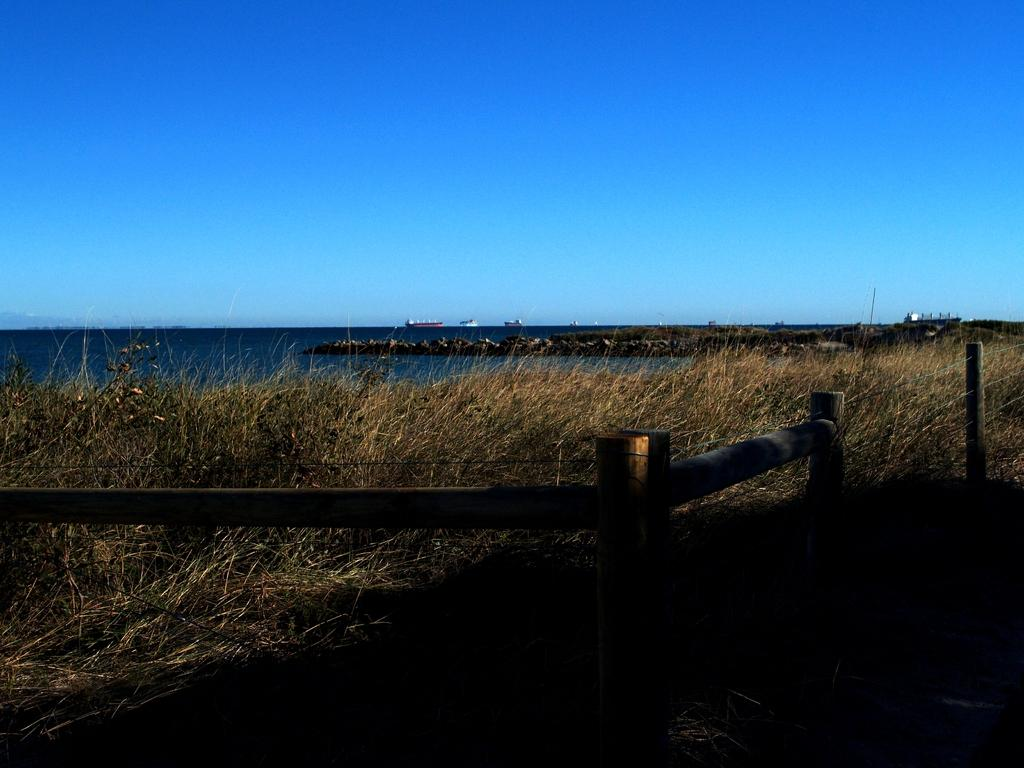What is located at the bottom of the image? There is a fence at the bottom of the image. What type of vegetation is in the center of the image? There is grass in the center of the image. What can be seen in the background of the image? There is water visible in the background of the image, and there are boats on the water. What is visible at the top of the image? The sky is visible at the top of the image. What type of rings can be seen on the boats in the image? There are no rings visible on the boats in the image. What authority figure is present in the image? There is no authority figure present in the image. 